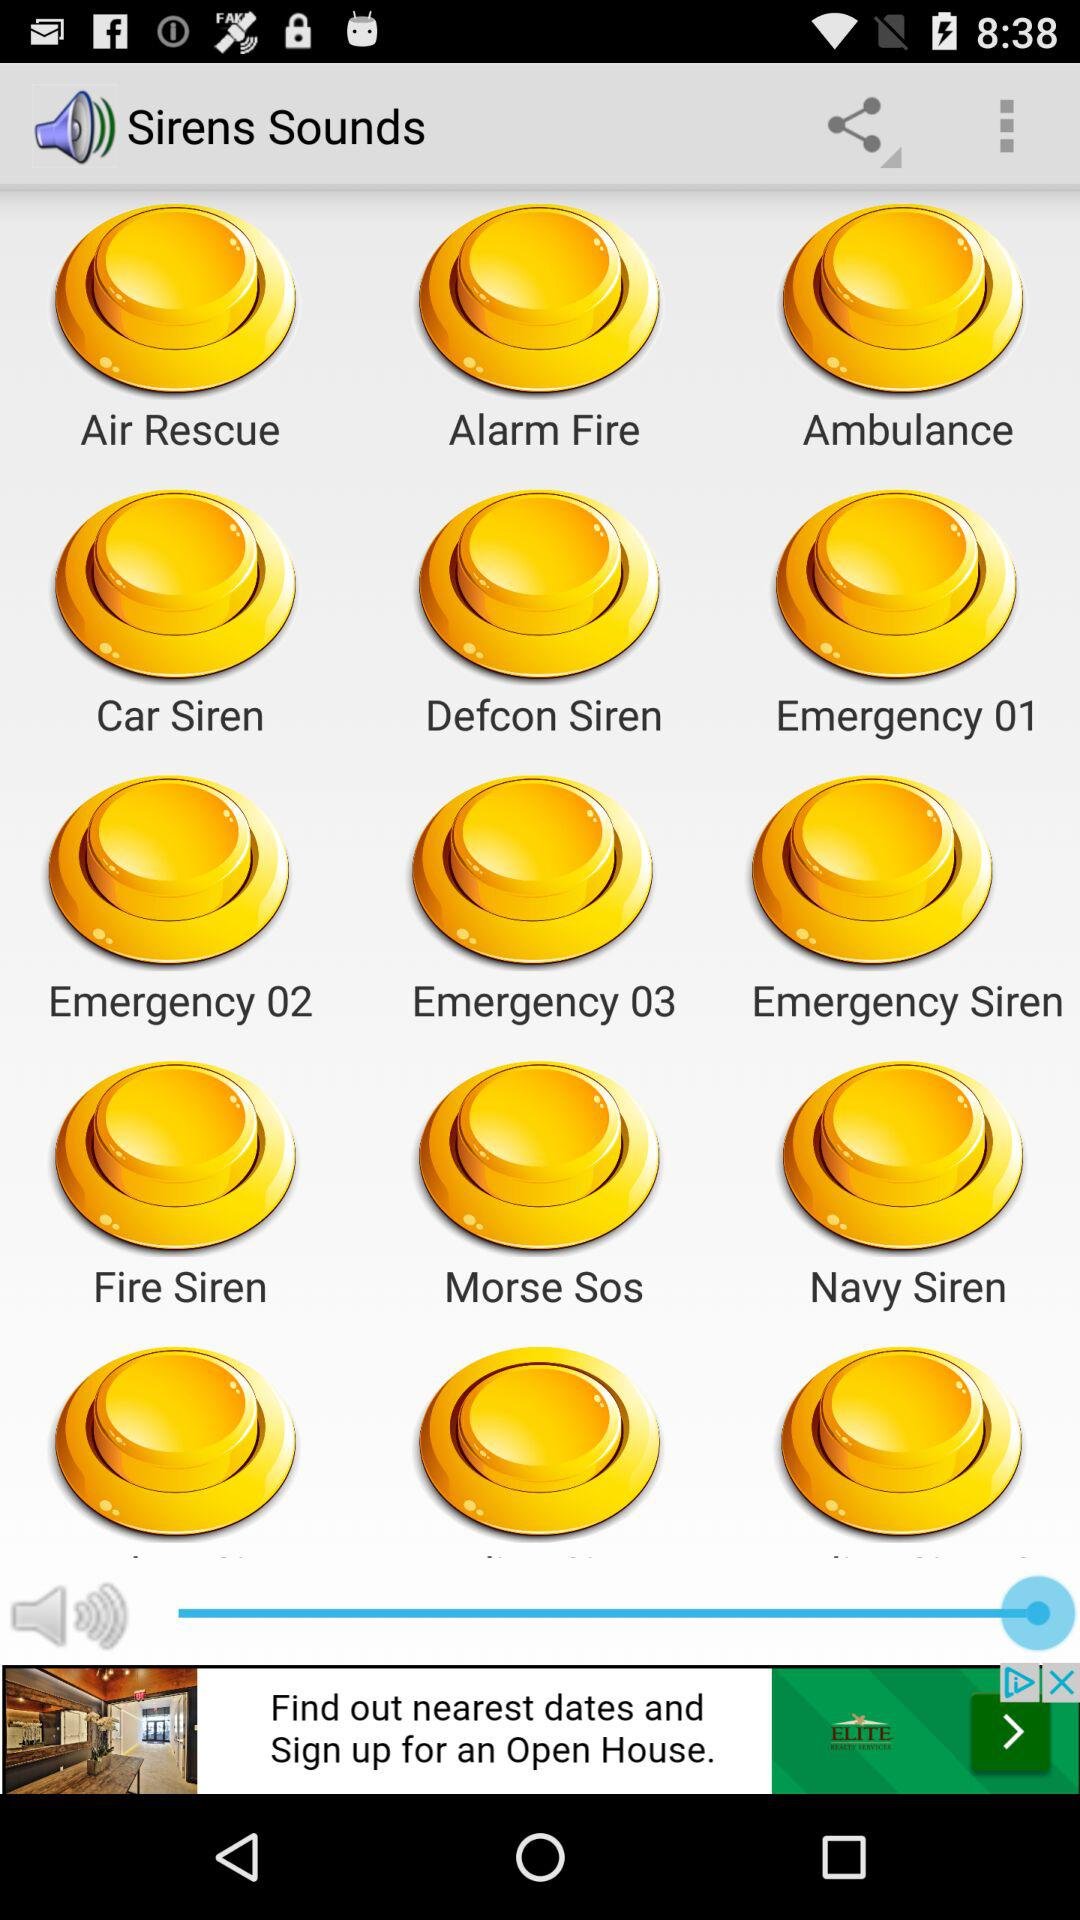Which siren sound has been selected?
When the provided information is insufficient, respond with <no answer>. <no answer> 